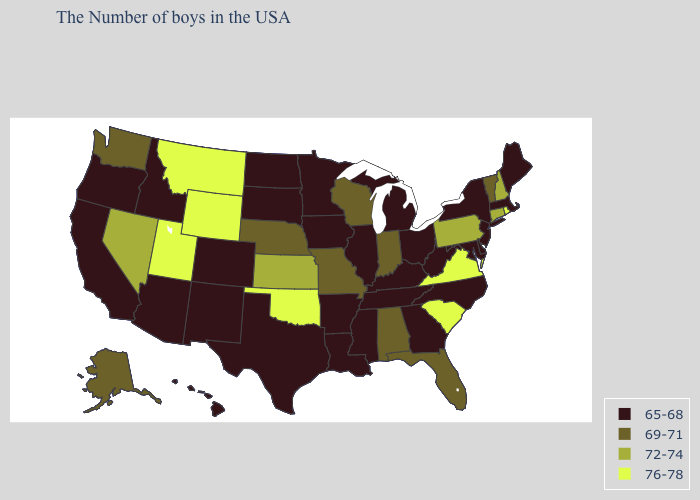What is the value of Georgia?
Short answer required. 65-68. What is the lowest value in the Northeast?
Be succinct. 65-68. What is the value of Montana?
Write a very short answer. 76-78. Does Delaware have a lower value than Arkansas?
Concise answer only. No. Name the states that have a value in the range 76-78?
Give a very brief answer. Rhode Island, Virginia, South Carolina, Oklahoma, Wyoming, Utah, Montana. Name the states that have a value in the range 65-68?
Give a very brief answer. Maine, Massachusetts, New York, New Jersey, Delaware, Maryland, North Carolina, West Virginia, Ohio, Georgia, Michigan, Kentucky, Tennessee, Illinois, Mississippi, Louisiana, Arkansas, Minnesota, Iowa, Texas, South Dakota, North Dakota, Colorado, New Mexico, Arizona, Idaho, California, Oregon, Hawaii. Among the states that border Nevada , which have the lowest value?
Answer briefly. Arizona, Idaho, California, Oregon. What is the lowest value in the Northeast?
Keep it brief. 65-68. What is the lowest value in the USA?
Quick response, please. 65-68. How many symbols are there in the legend?
Answer briefly. 4. Name the states that have a value in the range 76-78?
Short answer required. Rhode Island, Virginia, South Carolina, Oklahoma, Wyoming, Utah, Montana. Name the states that have a value in the range 65-68?
Answer briefly. Maine, Massachusetts, New York, New Jersey, Delaware, Maryland, North Carolina, West Virginia, Ohio, Georgia, Michigan, Kentucky, Tennessee, Illinois, Mississippi, Louisiana, Arkansas, Minnesota, Iowa, Texas, South Dakota, North Dakota, Colorado, New Mexico, Arizona, Idaho, California, Oregon, Hawaii. Among the states that border Ohio , does Michigan have the lowest value?
Give a very brief answer. Yes. What is the value of Vermont?
Give a very brief answer. 69-71. Name the states that have a value in the range 69-71?
Quick response, please. Vermont, Florida, Indiana, Alabama, Wisconsin, Missouri, Nebraska, Washington, Alaska. 